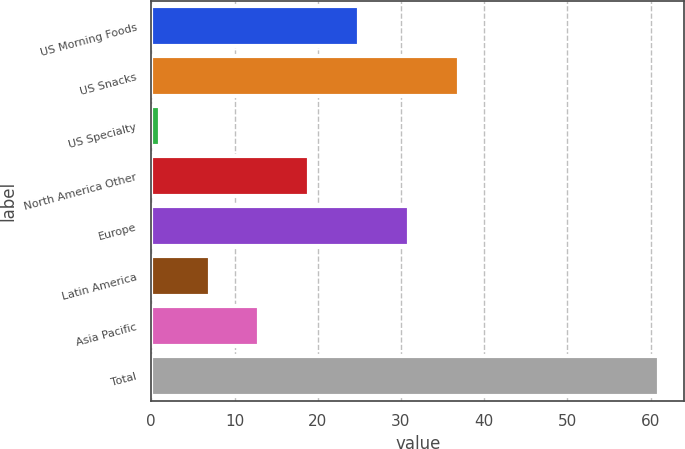Convert chart. <chart><loc_0><loc_0><loc_500><loc_500><bar_chart><fcel>US Morning Foods<fcel>US Snacks<fcel>US Specialty<fcel>North America Other<fcel>Europe<fcel>Latin America<fcel>Asia Pacific<fcel>Total<nl><fcel>25<fcel>37<fcel>1<fcel>19<fcel>31<fcel>7<fcel>13<fcel>61<nl></chart> 